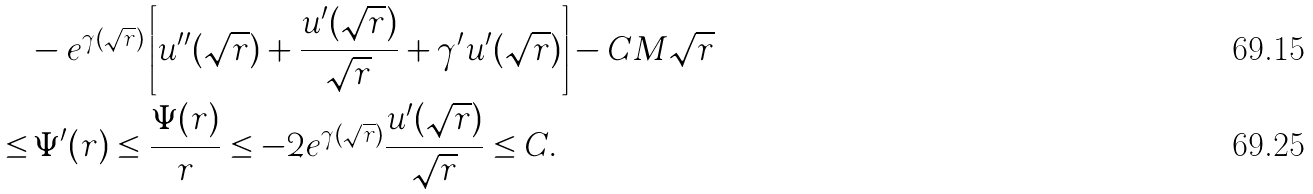Convert formula to latex. <formula><loc_0><loc_0><loc_500><loc_500>& - e ^ { \gamma ( \sqrt { r } ) } \left [ u ^ { \prime \prime } ( \sqrt { r } ) + \frac { u ^ { \prime } ( \sqrt { r } ) } { \sqrt { r } } + \gamma ^ { \prime } u ^ { \prime } ( \sqrt { r } ) \right ] - C M \sqrt { r } \\ \leq & \, \Psi ^ { \prime } ( r ) \leq \frac { \Psi ( r ) } { r } \leq - 2 e ^ { \gamma ( \sqrt { r } ) } \frac { u ^ { \prime } ( \sqrt { r } ) } { \sqrt { r } } \leq C .</formula> 